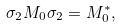<formula> <loc_0><loc_0><loc_500><loc_500>\sigma _ { 2 } M _ { 0 } \sigma _ { 2 } = M _ { 0 } ^ { \ast } ,</formula> 